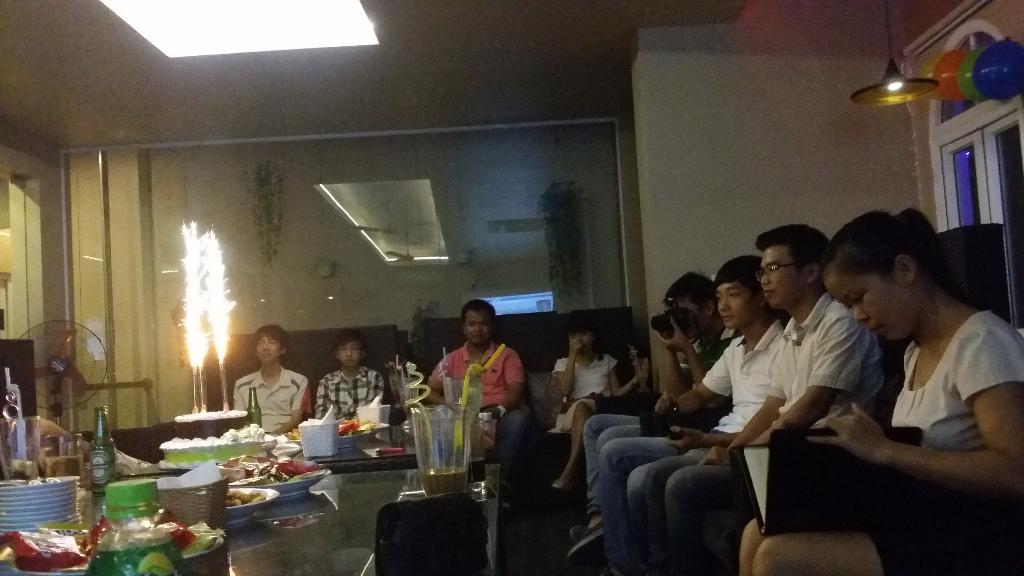What are the people in the image doing? The people in the image are sitting. What is on the table in the image? There is a cake, bottles, and plates on the table. What might be used to capture the moment in the image? A person is holding a camera. What is the name of the cloud formation visible in the image? There are no clouds visible in the image, as it is focused on people sitting and items on a table. 